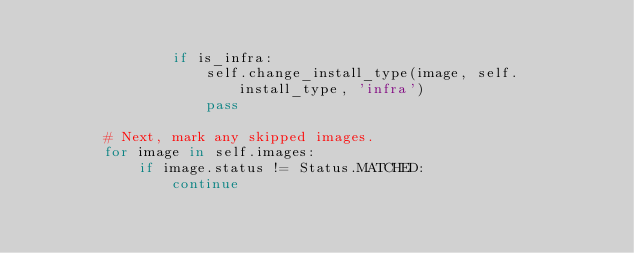Convert code to text. <code><loc_0><loc_0><loc_500><loc_500><_Python_>
                if is_infra:
                    self.change_install_type(image, self.install_type, 'infra')
                    pass

        # Next, mark any skipped images.
        for image in self.images:
            if image.status != Status.MATCHED:
                continue</code> 